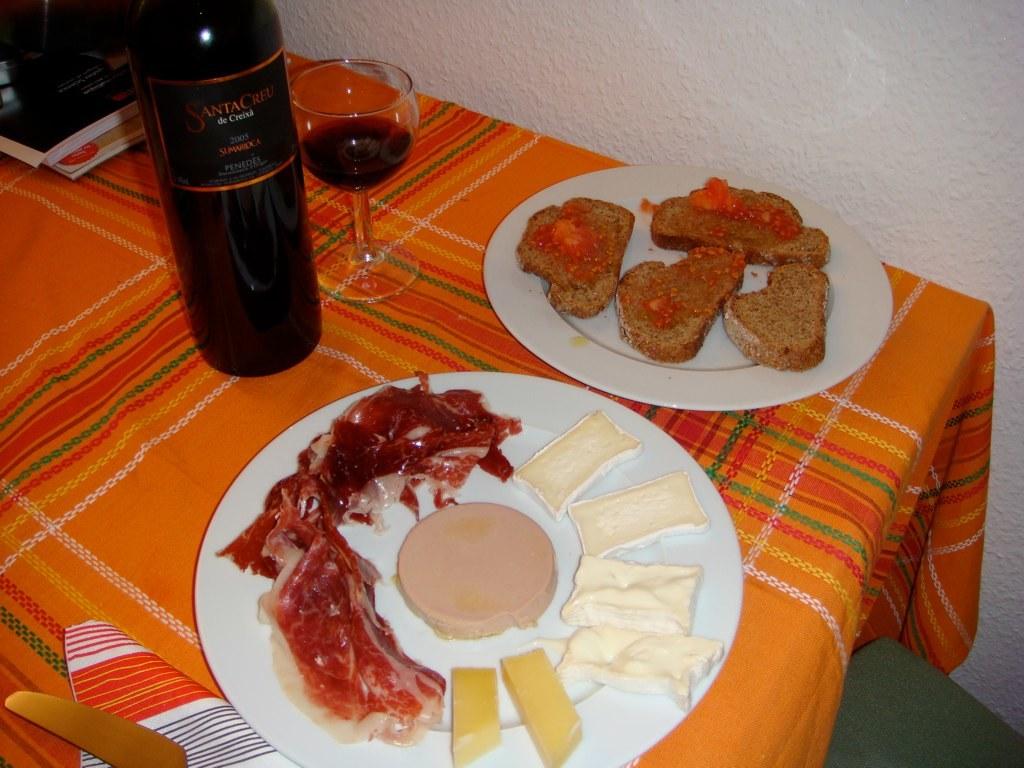What is the year this wine was bottled?
Offer a very short reply. Unanswerable. What brand is the wine?
Provide a short and direct response. Santa creu. 